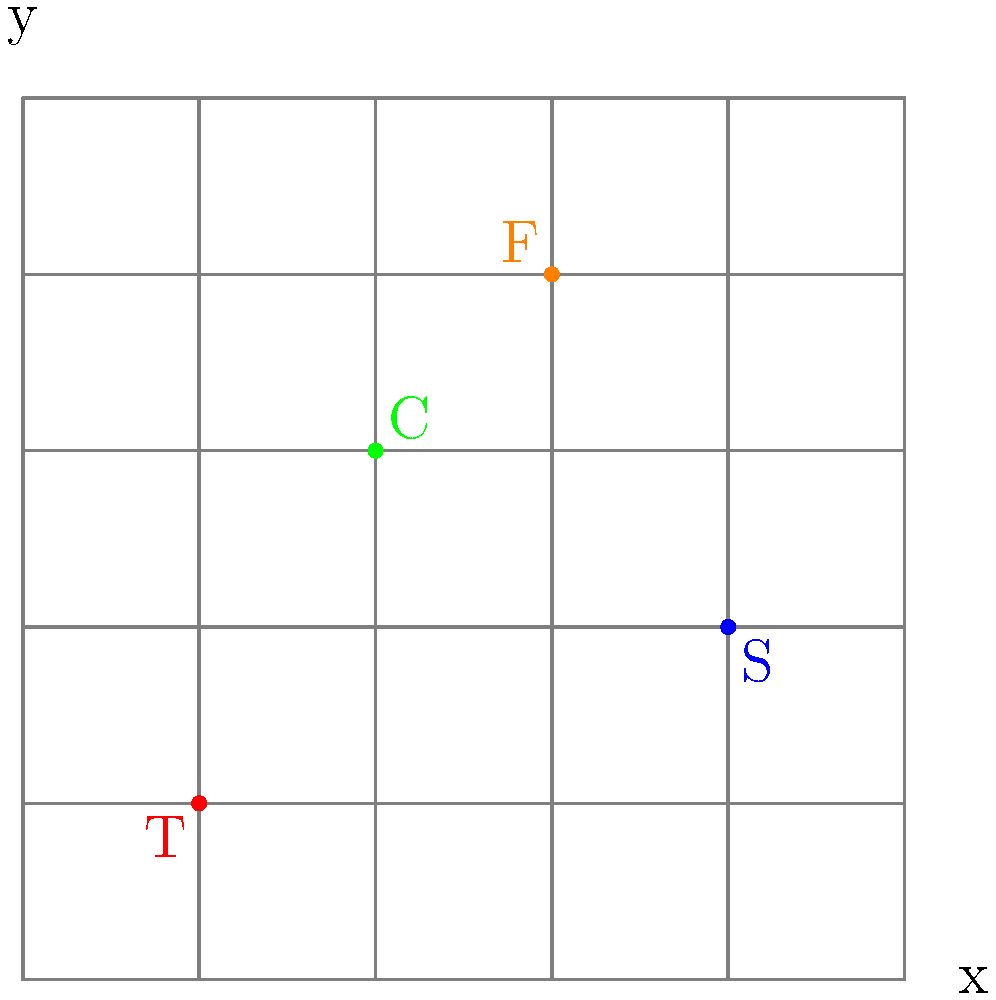In your small garden grid, you've planted different types of plants. The tomatoes (T) are at (1,1), carrots (C) at (2,3), sunflowers (S) at (4,2), and flowers (F) at (3,4). What is the total distance between the tomatoes and the sunflowers? To find the distance between two points on a coordinate plane, we can use the distance formula:

$$d = \sqrt{(x_2-x_1)^2 + (y_2-y_1)^2}$$

Where $(x_1,y_1)$ is the first point and $(x_2,y_2)$ is the second point.

Let's solve this step-by-step:

1. Identify the coordinates:
   Tomatoes (T): $(1,1)$
   Sunflowers (S): $(4,2)$

2. Plug these into the distance formula:
   $d = \sqrt{(4-1)^2 + (2-1)^2}$

3. Simplify inside the parentheses:
   $d = \sqrt{3^2 + 1^2}$

4. Calculate the squares:
   $d = \sqrt{9 + 1}$

5. Add under the square root:
   $d = \sqrt{10}$

6. The square root of 10 cannot be simplified further, so this is our final answer.

The total distance between the tomatoes and the sunflowers is $\sqrt{10}$ units.
Answer: $\sqrt{10}$ units 